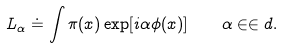<formula> <loc_0><loc_0><loc_500><loc_500>L _ { \alpha } \doteq \int \pi ( x ) \exp [ i \alpha \phi ( x ) ] \quad \alpha \in \in d .</formula> 